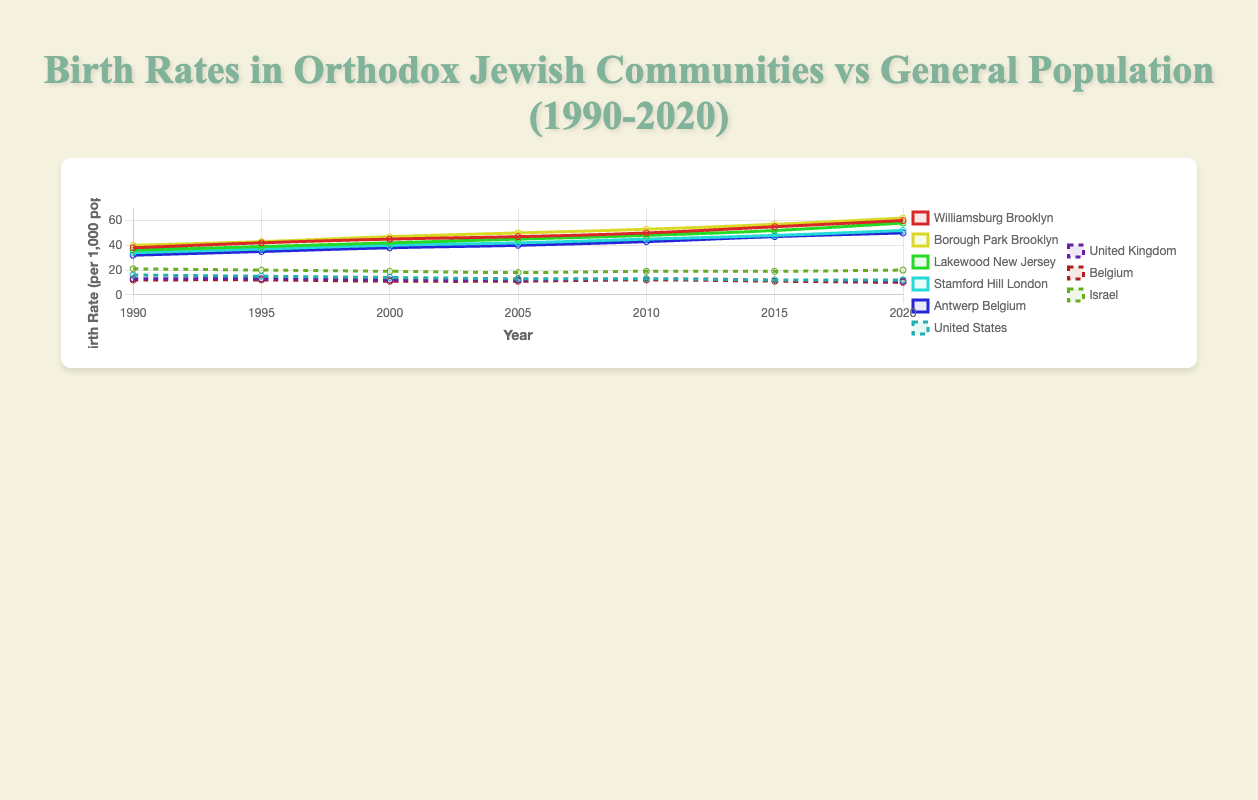How is the birth rate in Williamsburg, Brooklyn in 2000 compared to the general population of the United States in 2000? To compare, find the birth rate in Williamsburg, Brooklyn and the United States in 2000. Williamsburg, Brooklyn has a birth rate of 45 per 1,000 population and the United States has 14 per 1,000 population. Thus, the birth rate in Williamsburg, Brooklyn is higher.
Answer: Higher How did the birth rate change in Stamford Hill, London between 1990 and 2020? Calculate the difference in birth rate from 1990 (34) to 2020 (52). The change is 52 - 34 = 18.
Answer: Increased by 18 In which year did Antwerp, Belgium have the same birth rate as the United States? Locate the same birth rate in both Antwerp, Belgium and the United States. In 2000, Antwerp has a birth rate of 38 and the United States has 14. No matching year found.
Answer: No matching year Which location had the highest birth rate in 2015? Compare birth rates for all locations in 2015. Borough Park, Brooklyn has the highest birth rate at 57.
Answer: Borough Park, Brooklyn What is the average birth rate in Israel over the given years? Sum the birth rates over the years (21 + 20 + 19 + 18 + 19 + 19 + 20) = 136, then divide by the number of data points (7). The average is 136 / 7 ≈ 19.43.
Answer: 19.43 How does the birth rate in Lakewood, New Jersey in 2010 compare to that in Antwerp, Belgium in 2010? Compare the birth rates in 2010. Lakewood, New Jersey has a birth rate of 48 and Antwerp, Belgium has 43. Lakewood, New Jersey is higher.
Answer: Lakewood, New Jersey is higher What trend can be observed in the United Kingdom's birth rates from 1990 to 2020? Observe the general direction of birth rates in the United Kingdom from the data. The birth rates slightly decrease from 13 to 11.
Answer: Slightly decreasing Which community showed the most significant increase in birth rates from 1990 to 2020? Calculate the increase for each community by subtracting the 1990 birth rate from the 2020 birth rate. Williamsburg, Brooklyn has the highest increase from 38 to 60, representing a 22-point increase.
Answer: Williamsburg, Brooklyn How does the birth rate in Borough Park, Brooklyn in 2005 compare to the general population in Belgium in 2015? Compare Borough Park's 2005 birth rate (50) with Belgium's 2015 rate (11). Borough Park, Brooklyn is significantly higher.
Answer: Borough Park, Brooklyn is higher What is the maximum birth rate observed in any of the given orthodox Jewish communities over the years? Review the data points for all the communities. The highest observed birth rate is 62 in Borough Park, Brooklyn in 2020.
Answer: 62 